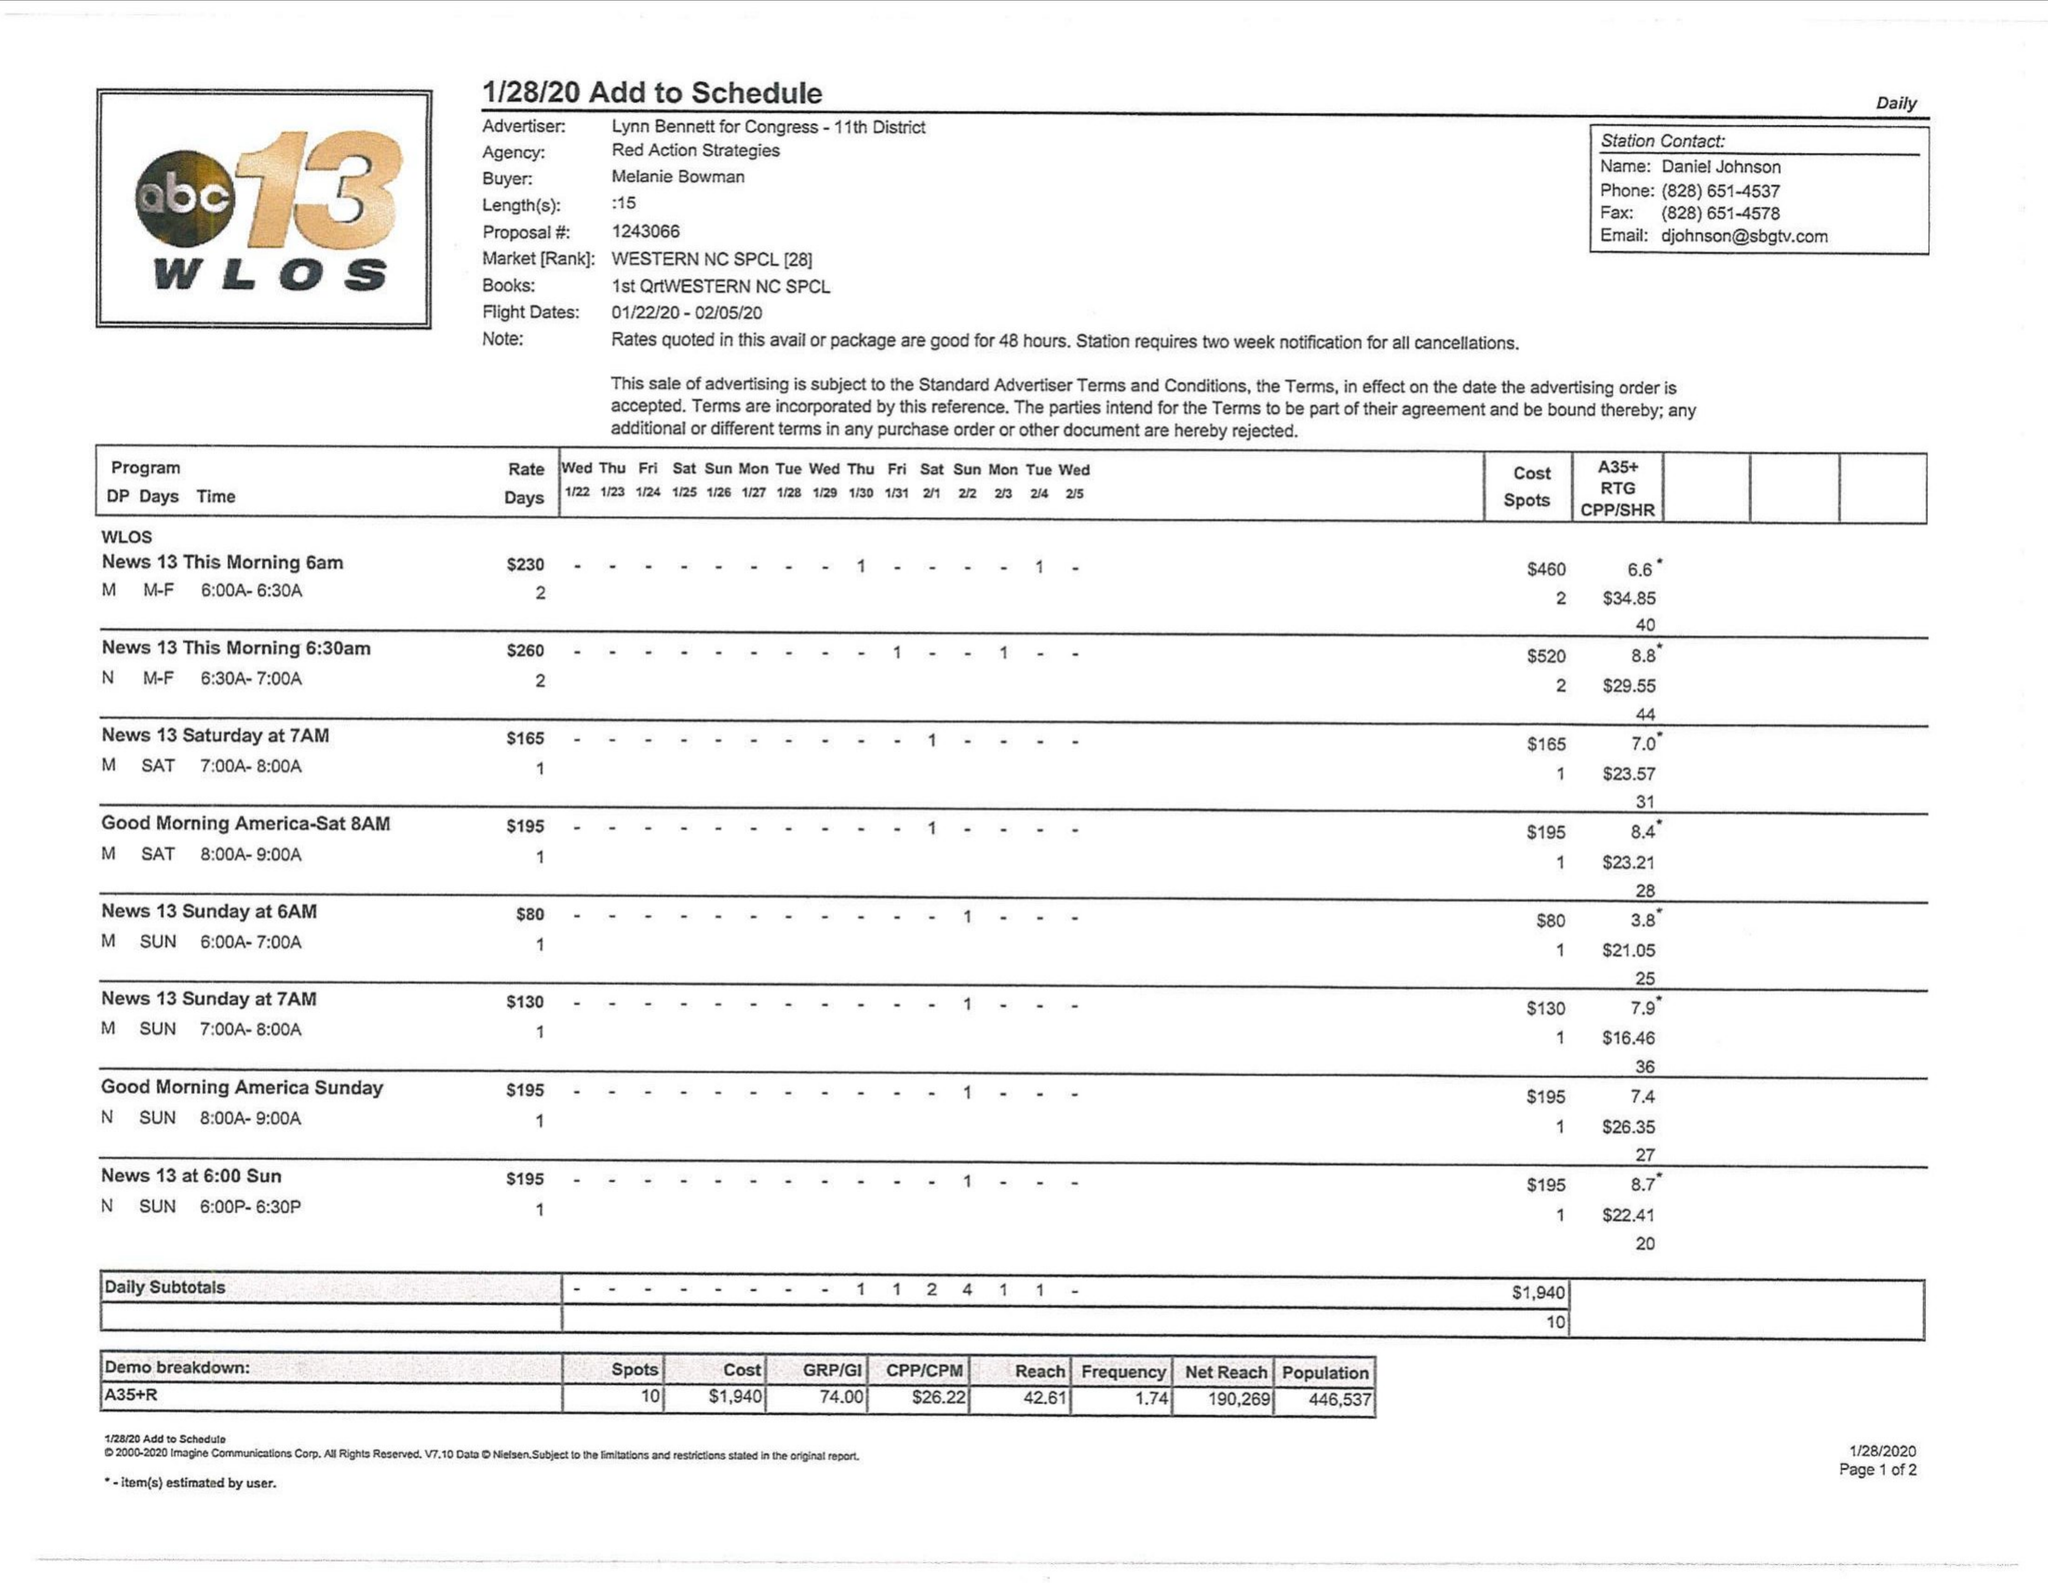What is the value for the flight_to?
Answer the question using a single word or phrase. 02/05/20 